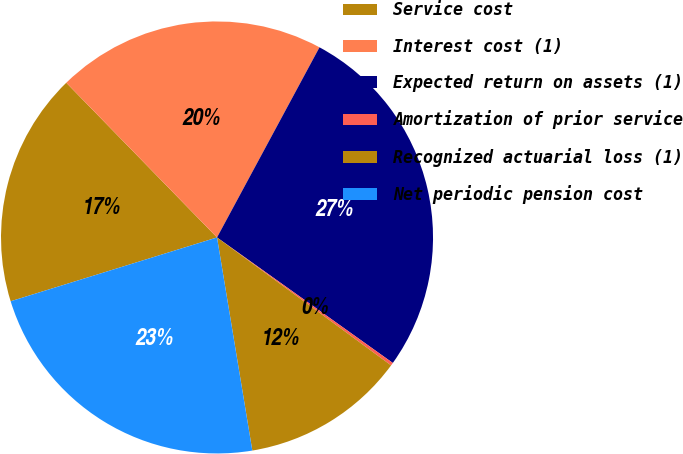Convert chart. <chart><loc_0><loc_0><loc_500><loc_500><pie_chart><fcel>Service cost<fcel>Interest cost (1)<fcel>Expected return on assets (1)<fcel>Amortization of prior service<fcel>Recognized actuarial loss (1)<fcel>Net periodic pension cost<nl><fcel>17.48%<fcel>20.16%<fcel>27.0%<fcel>0.22%<fcel>12.3%<fcel>22.84%<nl></chart> 